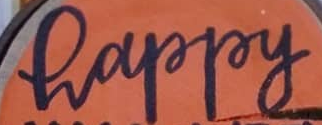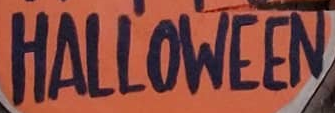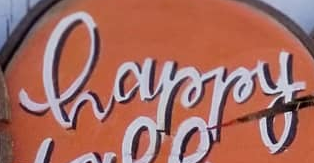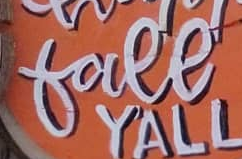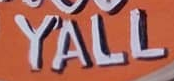Read the text content from these images in order, separated by a semicolon. happy; HALLOWEEN; happy; free; YALL 